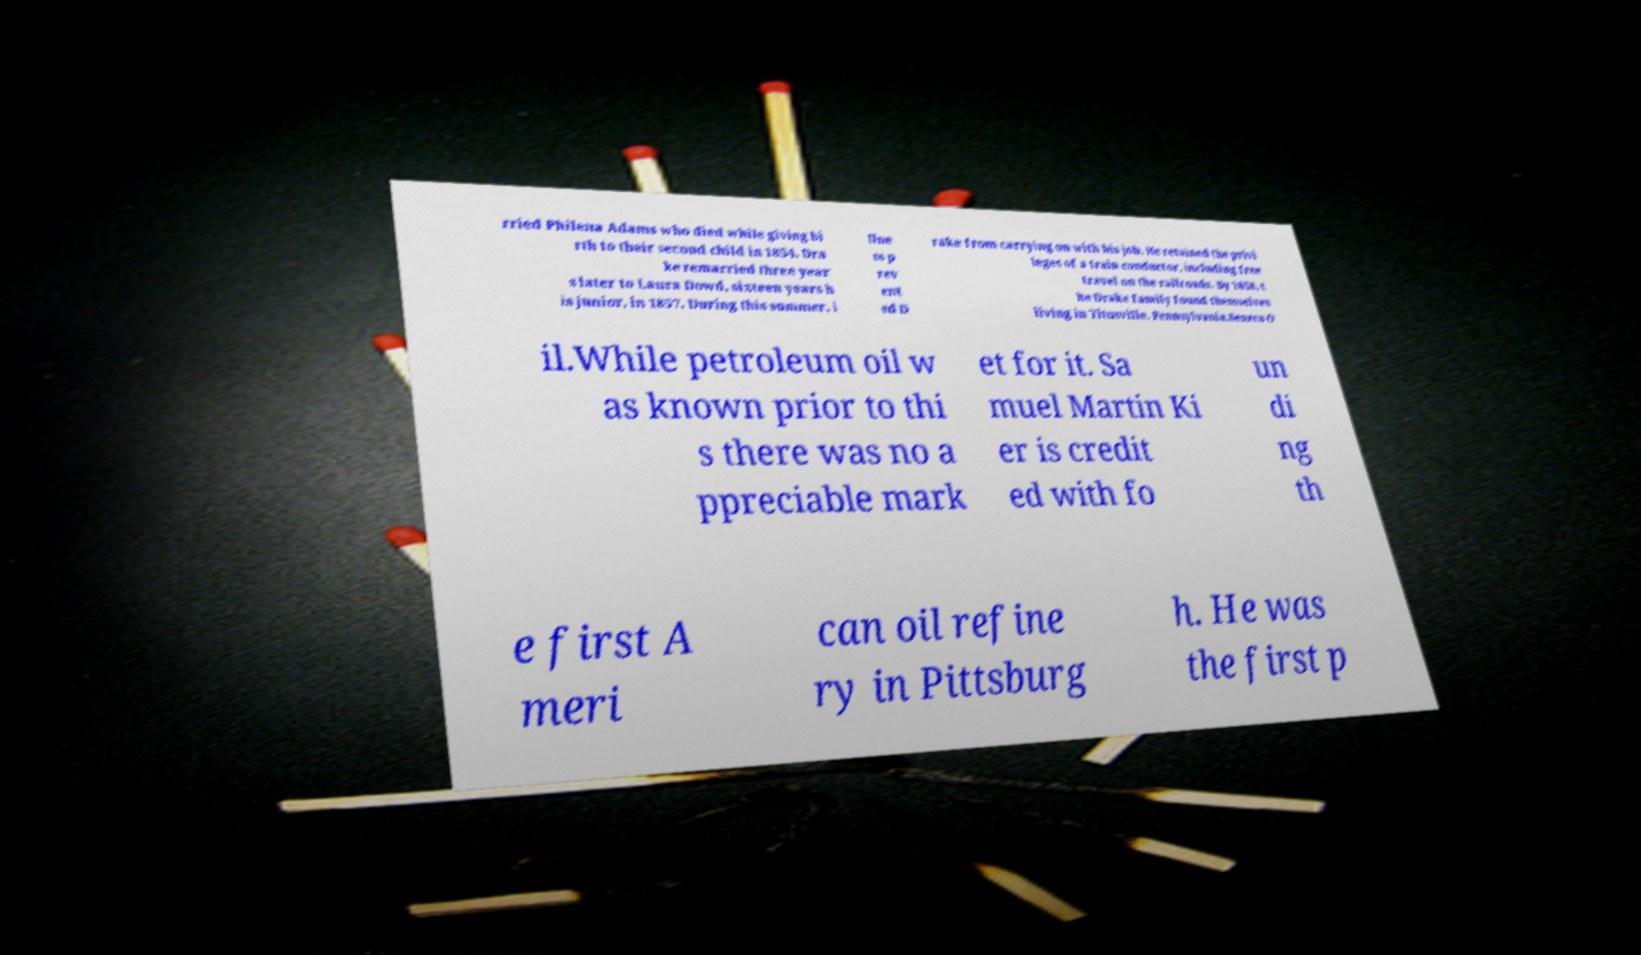There's text embedded in this image that I need extracted. Can you transcribe it verbatim? rried Philena Adams who died while giving bi rth to their second child in 1854. Dra ke remarried three year s later to Laura Dowd, sixteen years h is junior, in 1857. During this summer, i llne ss p rev ent ed D rake from carrying on with his job. He retained the privi leges of a train conductor, including free travel on the railroads. By 1858, t he Drake family found themselves living in Titusville, Pennsylvania.Seneca O il.While petroleum oil w as known prior to thi s there was no a ppreciable mark et for it. Sa muel Martin Ki er is credit ed with fo un di ng th e first A meri can oil refine ry in Pittsburg h. He was the first p 